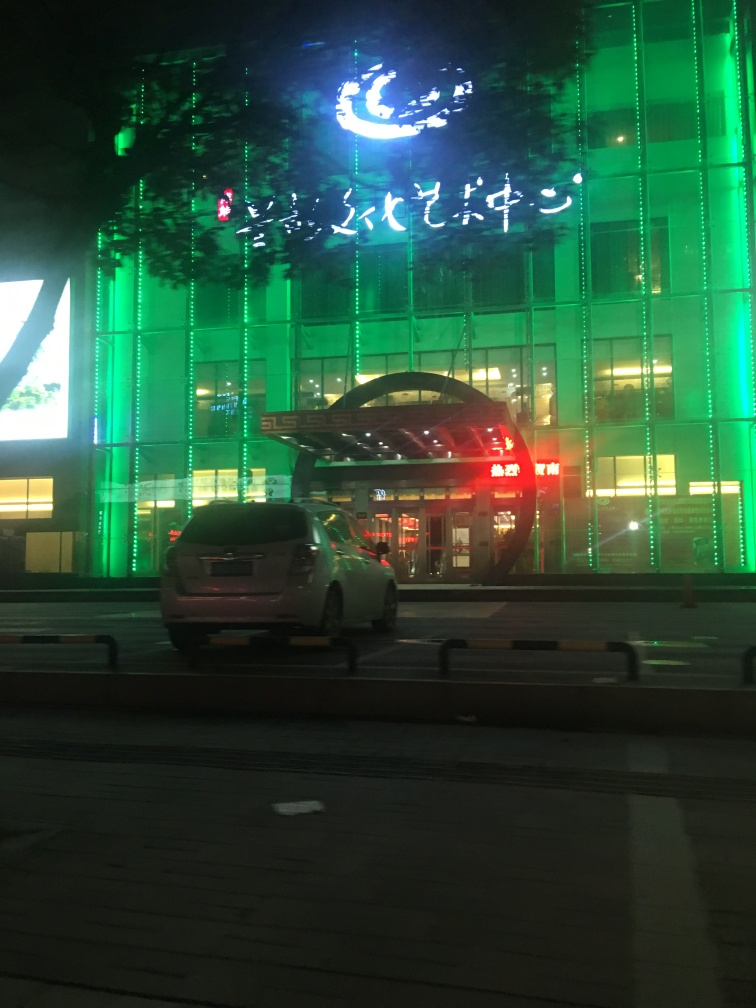What is the overall clarity of the image?
A. Blurry
B. Acceptable
C. Excellent The clarity of the image is acceptable; while the overall composition is discernible with some visible details, there is noticeable blur likely due to motion or low lighting conditions, which detracts from the sharpness one would associate with excellent clarity. 